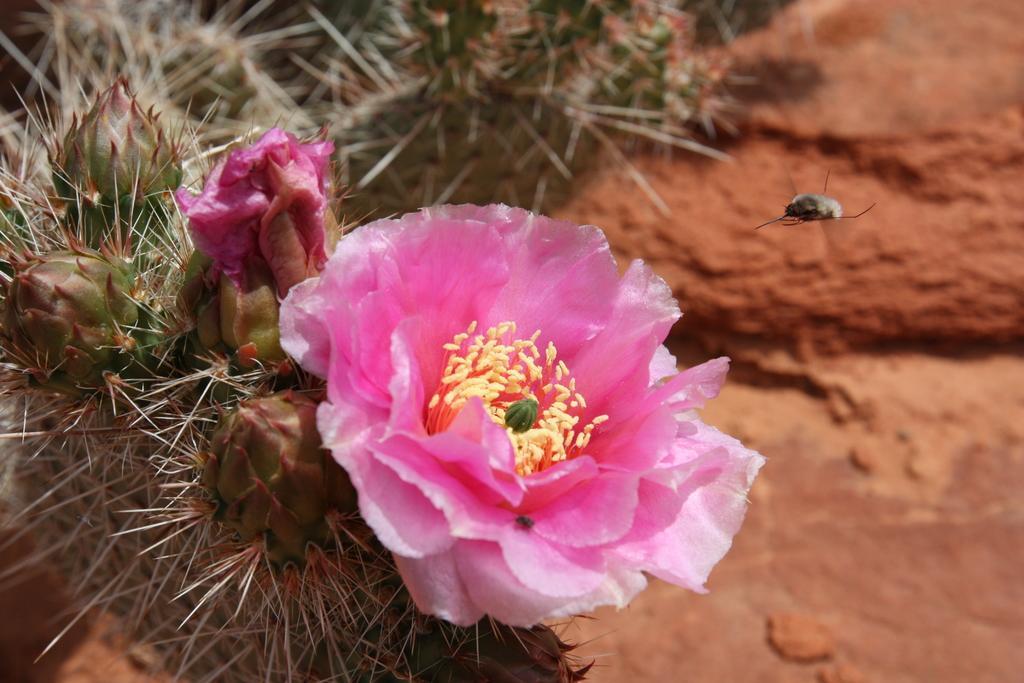Could you give a brief overview of what you see in this image? In this picture there is a flower which is in pink and yellow color and there is an insect flying in the air beside it. 